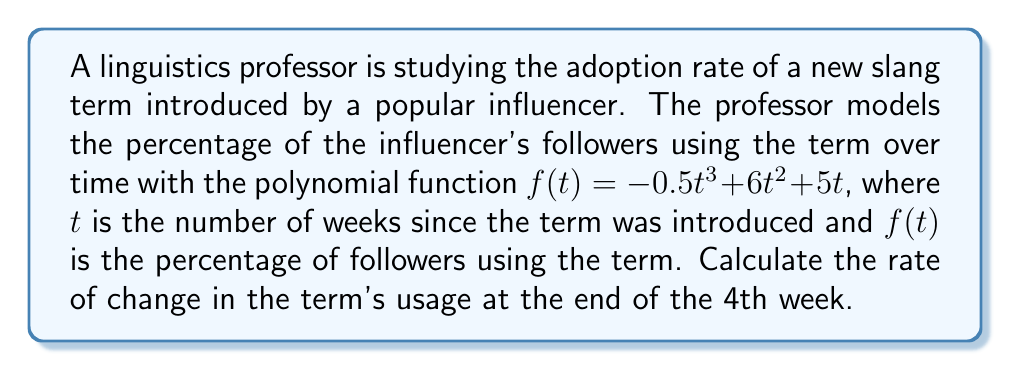Can you answer this question? To find the rate of change at a specific point, we need to calculate the derivative of the function and evaluate it at the given point. Here's how we do it:

1) The given function is $f(t) = -0.5t^3 + 6t^2 + 5t$

2) To find the derivative, we apply the power rule to each term:
   $f'(t) = (-0.5 \cdot 3)t^2 + (6 \cdot 2)t + 5$
   $f'(t) = -1.5t^2 + 12t + 5$

3) This derivative function $f'(t)$ represents the instantaneous rate of change at any point $t$.

4) We need to evaluate this at $t = 4$ (the end of the 4th week):
   $f'(4) = -1.5(4)^2 + 12(4) + 5$
   $f'(4) = -1.5(16) + 48 + 5$
   $f'(4) = -24 + 48 + 5$
   $f'(4) = 29$

5) Therefore, the rate of change at the end of the 4th week is 29 percentage points per week.
Answer: 29 percentage points per week 